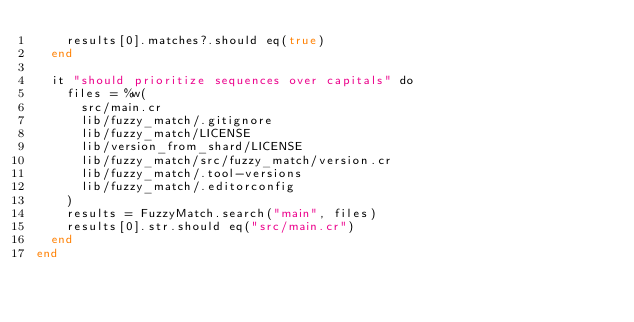<code> <loc_0><loc_0><loc_500><loc_500><_Crystal_>    results[0].matches?.should eq(true)
  end

  it "should prioritize sequences over capitals" do
    files = %w(
      src/main.cr
      lib/fuzzy_match/.gitignore
      lib/fuzzy_match/LICENSE
      lib/version_from_shard/LICENSE
      lib/fuzzy_match/src/fuzzy_match/version.cr
      lib/fuzzy_match/.tool-versions
      lib/fuzzy_match/.editorconfig
    )
    results = FuzzyMatch.search("main", files)
    results[0].str.should eq("src/main.cr")
  end
end
</code> 